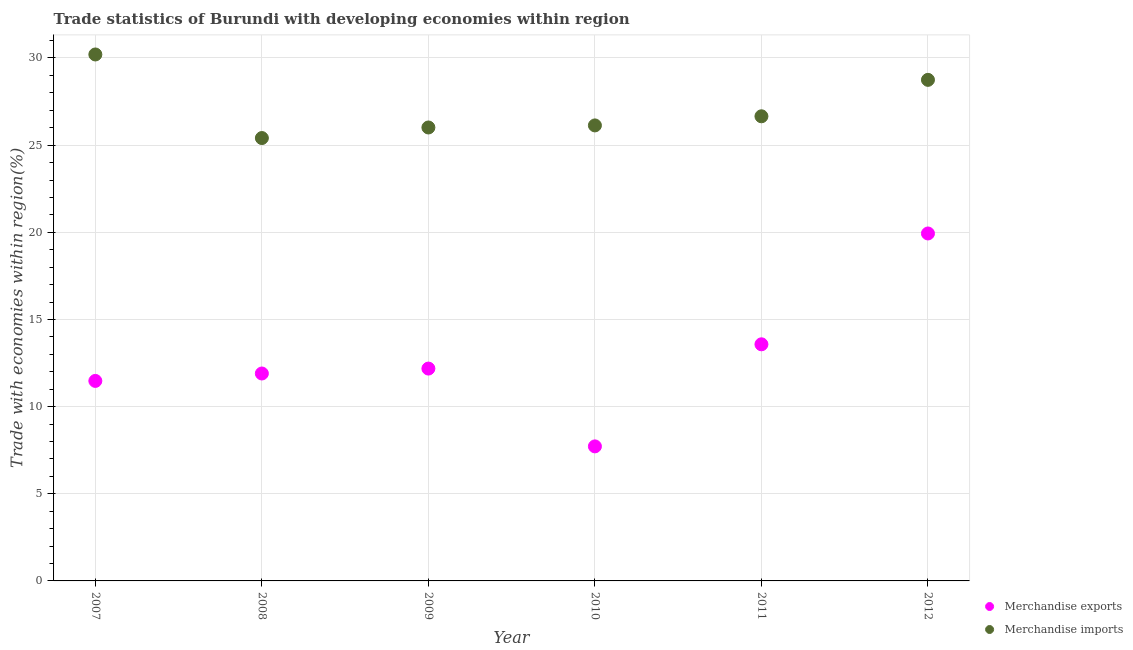Is the number of dotlines equal to the number of legend labels?
Provide a short and direct response. Yes. What is the merchandise exports in 2012?
Provide a succinct answer. 19.93. Across all years, what is the maximum merchandise exports?
Your answer should be very brief. 19.93. Across all years, what is the minimum merchandise exports?
Your response must be concise. 7.72. In which year was the merchandise imports maximum?
Your answer should be compact. 2007. In which year was the merchandise imports minimum?
Your answer should be compact. 2008. What is the total merchandise imports in the graph?
Provide a succinct answer. 163.16. What is the difference between the merchandise exports in 2009 and that in 2011?
Provide a short and direct response. -1.39. What is the difference between the merchandise imports in 2010 and the merchandise exports in 2009?
Offer a terse response. 13.95. What is the average merchandise exports per year?
Give a very brief answer. 12.8. In the year 2012, what is the difference between the merchandise imports and merchandise exports?
Offer a very short reply. 8.81. In how many years, is the merchandise imports greater than 23 %?
Give a very brief answer. 6. What is the ratio of the merchandise exports in 2007 to that in 2010?
Ensure brevity in your answer.  1.49. Is the difference between the merchandise exports in 2009 and 2012 greater than the difference between the merchandise imports in 2009 and 2012?
Provide a succinct answer. No. What is the difference between the highest and the second highest merchandise exports?
Ensure brevity in your answer.  6.36. What is the difference between the highest and the lowest merchandise imports?
Give a very brief answer. 4.79. Is the sum of the merchandise imports in 2007 and 2008 greater than the maximum merchandise exports across all years?
Make the answer very short. Yes. Does the merchandise imports monotonically increase over the years?
Offer a very short reply. No. How many years are there in the graph?
Keep it short and to the point. 6. Are the values on the major ticks of Y-axis written in scientific E-notation?
Provide a succinct answer. No. Does the graph contain grids?
Offer a terse response. Yes. Where does the legend appear in the graph?
Offer a terse response. Bottom right. How many legend labels are there?
Keep it short and to the point. 2. How are the legend labels stacked?
Your answer should be compact. Vertical. What is the title of the graph?
Offer a very short reply. Trade statistics of Burundi with developing economies within region. Does "From World Bank" appear as one of the legend labels in the graph?
Make the answer very short. No. What is the label or title of the Y-axis?
Offer a terse response. Trade with economies within region(%). What is the Trade with economies within region(%) of Merchandise exports in 2007?
Your answer should be compact. 11.47. What is the Trade with economies within region(%) of Merchandise imports in 2007?
Provide a succinct answer. 30.2. What is the Trade with economies within region(%) of Merchandise exports in 2008?
Your answer should be very brief. 11.9. What is the Trade with economies within region(%) in Merchandise imports in 2008?
Make the answer very short. 25.41. What is the Trade with economies within region(%) in Merchandise exports in 2009?
Provide a short and direct response. 12.18. What is the Trade with economies within region(%) in Merchandise imports in 2009?
Provide a short and direct response. 26.01. What is the Trade with economies within region(%) in Merchandise exports in 2010?
Provide a succinct answer. 7.72. What is the Trade with economies within region(%) in Merchandise imports in 2010?
Make the answer very short. 26.13. What is the Trade with economies within region(%) in Merchandise exports in 2011?
Your answer should be compact. 13.57. What is the Trade with economies within region(%) in Merchandise imports in 2011?
Make the answer very short. 26.66. What is the Trade with economies within region(%) in Merchandise exports in 2012?
Offer a very short reply. 19.93. What is the Trade with economies within region(%) in Merchandise imports in 2012?
Make the answer very short. 28.75. Across all years, what is the maximum Trade with economies within region(%) in Merchandise exports?
Your answer should be compact. 19.93. Across all years, what is the maximum Trade with economies within region(%) of Merchandise imports?
Provide a short and direct response. 30.2. Across all years, what is the minimum Trade with economies within region(%) in Merchandise exports?
Keep it short and to the point. 7.72. Across all years, what is the minimum Trade with economies within region(%) of Merchandise imports?
Offer a very short reply. 25.41. What is the total Trade with economies within region(%) of Merchandise exports in the graph?
Give a very brief answer. 76.78. What is the total Trade with economies within region(%) of Merchandise imports in the graph?
Give a very brief answer. 163.16. What is the difference between the Trade with economies within region(%) in Merchandise exports in 2007 and that in 2008?
Offer a very short reply. -0.43. What is the difference between the Trade with economies within region(%) of Merchandise imports in 2007 and that in 2008?
Provide a succinct answer. 4.79. What is the difference between the Trade with economies within region(%) in Merchandise exports in 2007 and that in 2009?
Ensure brevity in your answer.  -0.71. What is the difference between the Trade with economies within region(%) in Merchandise imports in 2007 and that in 2009?
Keep it short and to the point. 4.19. What is the difference between the Trade with economies within region(%) in Merchandise exports in 2007 and that in 2010?
Your answer should be compact. 3.76. What is the difference between the Trade with economies within region(%) of Merchandise imports in 2007 and that in 2010?
Make the answer very short. 4.07. What is the difference between the Trade with economies within region(%) of Merchandise exports in 2007 and that in 2011?
Your answer should be compact. -2.1. What is the difference between the Trade with economies within region(%) of Merchandise imports in 2007 and that in 2011?
Ensure brevity in your answer.  3.55. What is the difference between the Trade with economies within region(%) in Merchandise exports in 2007 and that in 2012?
Your answer should be very brief. -8.46. What is the difference between the Trade with economies within region(%) in Merchandise imports in 2007 and that in 2012?
Offer a very short reply. 1.46. What is the difference between the Trade with economies within region(%) of Merchandise exports in 2008 and that in 2009?
Make the answer very short. -0.28. What is the difference between the Trade with economies within region(%) in Merchandise imports in 2008 and that in 2009?
Your answer should be compact. -0.61. What is the difference between the Trade with economies within region(%) of Merchandise exports in 2008 and that in 2010?
Keep it short and to the point. 4.18. What is the difference between the Trade with economies within region(%) of Merchandise imports in 2008 and that in 2010?
Ensure brevity in your answer.  -0.72. What is the difference between the Trade with economies within region(%) in Merchandise exports in 2008 and that in 2011?
Your response must be concise. -1.67. What is the difference between the Trade with economies within region(%) in Merchandise imports in 2008 and that in 2011?
Your response must be concise. -1.25. What is the difference between the Trade with economies within region(%) in Merchandise exports in 2008 and that in 2012?
Your answer should be compact. -8.03. What is the difference between the Trade with economies within region(%) of Merchandise imports in 2008 and that in 2012?
Offer a terse response. -3.34. What is the difference between the Trade with economies within region(%) of Merchandise exports in 2009 and that in 2010?
Provide a short and direct response. 4.46. What is the difference between the Trade with economies within region(%) in Merchandise imports in 2009 and that in 2010?
Keep it short and to the point. -0.12. What is the difference between the Trade with economies within region(%) of Merchandise exports in 2009 and that in 2011?
Your answer should be compact. -1.39. What is the difference between the Trade with economies within region(%) of Merchandise imports in 2009 and that in 2011?
Your answer should be very brief. -0.64. What is the difference between the Trade with economies within region(%) in Merchandise exports in 2009 and that in 2012?
Offer a very short reply. -7.75. What is the difference between the Trade with economies within region(%) in Merchandise imports in 2009 and that in 2012?
Offer a very short reply. -2.73. What is the difference between the Trade with economies within region(%) of Merchandise exports in 2010 and that in 2011?
Offer a very short reply. -5.86. What is the difference between the Trade with economies within region(%) in Merchandise imports in 2010 and that in 2011?
Offer a very short reply. -0.52. What is the difference between the Trade with economies within region(%) in Merchandise exports in 2010 and that in 2012?
Offer a very short reply. -12.21. What is the difference between the Trade with economies within region(%) in Merchandise imports in 2010 and that in 2012?
Keep it short and to the point. -2.61. What is the difference between the Trade with economies within region(%) of Merchandise exports in 2011 and that in 2012?
Your answer should be very brief. -6.36. What is the difference between the Trade with economies within region(%) in Merchandise imports in 2011 and that in 2012?
Offer a very short reply. -2.09. What is the difference between the Trade with economies within region(%) in Merchandise exports in 2007 and the Trade with economies within region(%) in Merchandise imports in 2008?
Give a very brief answer. -13.93. What is the difference between the Trade with economies within region(%) in Merchandise exports in 2007 and the Trade with economies within region(%) in Merchandise imports in 2009?
Your answer should be compact. -14.54. What is the difference between the Trade with economies within region(%) in Merchandise exports in 2007 and the Trade with economies within region(%) in Merchandise imports in 2010?
Ensure brevity in your answer.  -14.66. What is the difference between the Trade with economies within region(%) of Merchandise exports in 2007 and the Trade with economies within region(%) of Merchandise imports in 2011?
Offer a very short reply. -15.18. What is the difference between the Trade with economies within region(%) of Merchandise exports in 2007 and the Trade with economies within region(%) of Merchandise imports in 2012?
Offer a very short reply. -17.27. What is the difference between the Trade with economies within region(%) in Merchandise exports in 2008 and the Trade with economies within region(%) in Merchandise imports in 2009?
Your answer should be very brief. -14.11. What is the difference between the Trade with economies within region(%) in Merchandise exports in 2008 and the Trade with economies within region(%) in Merchandise imports in 2010?
Your response must be concise. -14.23. What is the difference between the Trade with economies within region(%) in Merchandise exports in 2008 and the Trade with economies within region(%) in Merchandise imports in 2011?
Offer a terse response. -14.76. What is the difference between the Trade with economies within region(%) of Merchandise exports in 2008 and the Trade with economies within region(%) of Merchandise imports in 2012?
Provide a succinct answer. -16.85. What is the difference between the Trade with economies within region(%) of Merchandise exports in 2009 and the Trade with economies within region(%) of Merchandise imports in 2010?
Keep it short and to the point. -13.95. What is the difference between the Trade with economies within region(%) in Merchandise exports in 2009 and the Trade with economies within region(%) in Merchandise imports in 2011?
Provide a succinct answer. -14.47. What is the difference between the Trade with economies within region(%) in Merchandise exports in 2009 and the Trade with economies within region(%) in Merchandise imports in 2012?
Your answer should be compact. -16.56. What is the difference between the Trade with economies within region(%) in Merchandise exports in 2010 and the Trade with economies within region(%) in Merchandise imports in 2011?
Your response must be concise. -18.94. What is the difference between the Trade with economies within region(%) of Merchandise exports in 2010 and the Trade with economies within region(%) of Merchandise imports in 2012?
Your answer should be very brief. -21.03. What is the difference between the Trade with economies within region(%) in Merchandise exports in 2011 and the Trade with economies within region(%) in Merchandise imports in 2012?
Provide a short and direct response. -15.17. What is the average Trade with economies within region(%) of Merchandise exports per year?
Offer a terse response. 12.8. What is the average Trade with economies within region(%) in Merchandise imports per year?
Ensure brevity in your answer.  27.19. In the year 2007, what is the difference between the Trade with economies within region(%) in Merchandise exports and Trade with economies within region(%) in Merchandise imports?
Make the answer very short. -18.73. In the year 2008, what is the difference between the Trade with economies within region(%) of Merchandise exports and Trade with economies within region(%) of Merchandise imports?
Ensure brevity in your answer.  -13.51. In the year 2009, what is the difference between the Trade with economies within region(%) in Merchandise exports and Trade with economies within region(%) in Merchandise imports?
Ensure brevity in your answer.  -13.83. In the year 2010, what is the difference between the Trade with economies within region(%) of Merchandise exports and Trade with economies within region(%) of Merchandise imports?
Your response must be concise. -18.41. In the year 2011, what is the difference between the Trade with economies within region(%) in Merchandise exports and Trade with economies within region(%) in Merchandise imports?
Your answer should be compact. -13.08. In the year 2012, what is the difference between the Trade with economies within region(%) of Merchandise exports and Trade with economies within region(%) of Merchandise imports?
Provide a short and direct response. -8.81. What is the ratio of the Trade with economies within region(%) in Merchandise exports in 2007 to that in 2008?
Keep it short and to the point. 0.96. What is the ratio of the Trade with economies within region(%) in Merchandise imports in 2007 to that in 2008?
Ensure brevity in your answer.  1.19. What is the ratio of the Trade with economies within region(%) of Merchandise exports in 2007 to that in 2009?
Provide a short and direct response. 0.94. What is the ratio of the Trade with economies within region(%) in Merchandise imports in 2007 to that in 2009?
Offer a very short reply. 1.16. What is the ratio of the Trade with economies within region(%) of Merchandise exports in 2007 to that in 2010?
Your answer should be compact. 1.49. What is the ratio of the Trade with economies within region(%) of Merchandise imports in 2007 to that in 2010?
Offer a very short reply. 1.16. What is the ratio of the Trade with economies within region(%) of Merchandise exports in 2007 to that in 2011?
Make the answer very short. 0.85. What is the ratio of the Trade with economies within region(%) of Merchandise imports in 2007 to that in 2011?
Provide a succinct answer. 1.13. What is the ratio of the Trade with economies within region(%) in Merchandise exports in 2007 to that in 2012?
Your response must be concise. 0.58. What is the ratio of the Trade with economies within region(%) of Merchandise imports in 2007 to that in 2012?
Offer a very short reply. 1.05. What is the ratio of the Trade with economies within region(%) of Merchandise exports in 2008 to that in 2009?
Ensure brevity in your answer.  0.98. What is the ratio of the Trade with economies within region(%) in Merchandise imports in 2008 to that in 2009?
Make the answer very short. 0.98. What is the ratio of the Trade with economies within region(%) in Merchandise exports in 2008 to that in 2010?
Your answer should be very brief. 1.54. What is the ratio of the Trade with economies within region(%) in Merchandise imports in 2008 to that in 2010?
Your answer should be very brief. 0.97. What is the ratio of the Trade with economies within region(%) in Merchandise exports in 2008 to that in 2011?
Provide a succinct answer. 0.88. What is the ratio of the Trade with economies within region(%) in Merchandise imports in 2008 to that in 2011?
Offer a terse response. 0.95. What is the ratio of the Trade with economies within region(%) of Merchandise exports in 2008 to that in 2012?
Offer a terse response. 0.6. What is the ratio of the Trade with economies within region(%) of Merchandise imports in 2008 to that in 2012?
Give a very brief answer. 0.88. What is the ratio of the Trade with economies within region(%) of Merchandise exports in 2009 to that in 2010?
Make the answer very short. 1.58. What is the ratio of the Trade with economies within region(%) of Merchandise exports in 2009 to that in 2011?
Provide a succinct answer. 0.9. What is the ratio of the Trade with economies within region(%) of Merchandise imports in 2009 to that in 2011?
Offer a terse response. 0.98. What is the ratio of the Trade with economies within region(%) of Merchandise exports in 2009 to that in 2012?
Ensure brevity in your answer.  0.61. What is the ratio of the Trade with economies within region(%) of Merchandise imports in 2009 to that in 2012?
Give a very brief answer. 0.91. What is the ratio of the Trade with economies within region(%) in Merchandise exports in 2010 to that in 2011?
Ensure brevity in your answer.  0.57. What is the ratio of the Trade with economies within region(%) in Merchandise imports in 2010 to that in 2011?
Provide a succinct answer. 0.98. What is the ratio of the Trade with economies within region(%) in Merchandise exports in 2010 to that in 2012?
Offer a very short reply. 0.39. What is the ratio of the Trade with economies within region(%) of Merchandise imports in 2010 to that in 2012?
Make the answer very short. 0.91. What is the ratio of the Trade with economies within region(%) in Merchandise exports in 2011 to that in 2012?
Give a very brief answer. 0.68. What is the ratio of the Trade with economies within region(%) of Merchandise imports in 2011 to that in 2012?
Offer a very short reply. 0.93. What is the difference between the highest and the second highest Trade with economies within region(%) of Merchandise exports?
Give a very brief answer. 6.36. What is the difference between the highest and the second highest Trade with economies within region(%) in Merchandise imports?
Your response must be concise. 1.46. What is the difference between the highest and the lowest Trade with economies within region(%) of Merchandise exports?
Offer a very short reply. 12.21. What is the difference between the highest and the lowest Trade with economies within region(%) in Merchandise imports?
Make the answer very short. 4.79. 